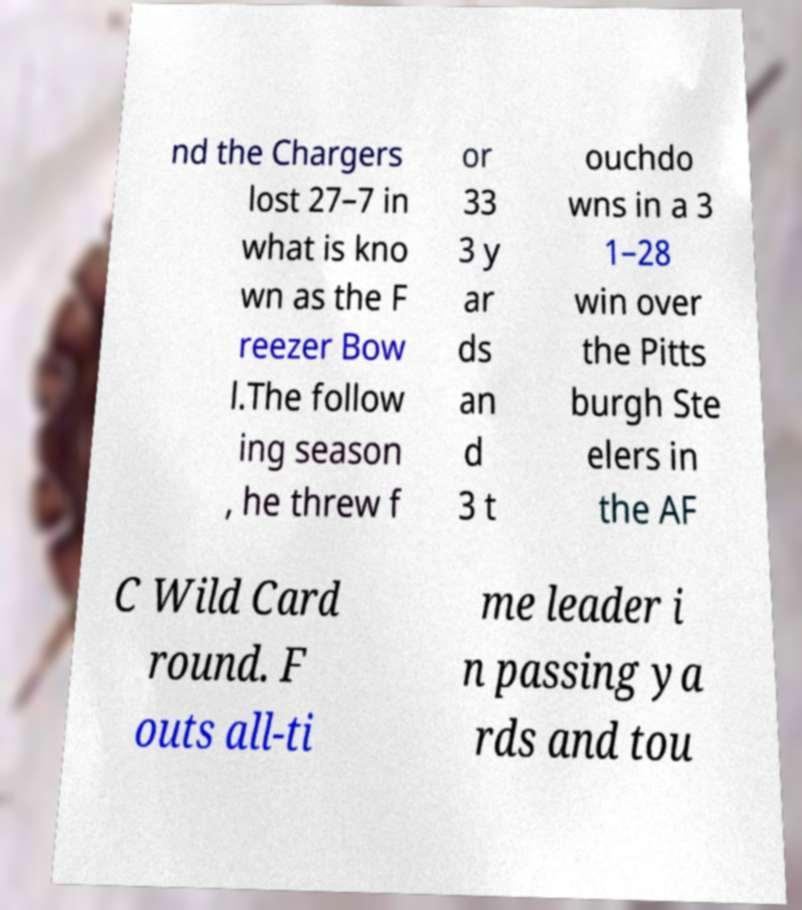Could you assist in decoding the text presented in this image and type it out clearly? nd the Chargers lost 27–7 in what is kno wn as the F reezer Bow l.The follow ing season , he threw f or 33 3 y ar ds an d 3 t ouchdo wns in a 3 1–28 win over the Pitts burgh Ste elers in the AF C Wild Card round. F outs all-ti me leader i n passing ya rds and tou 